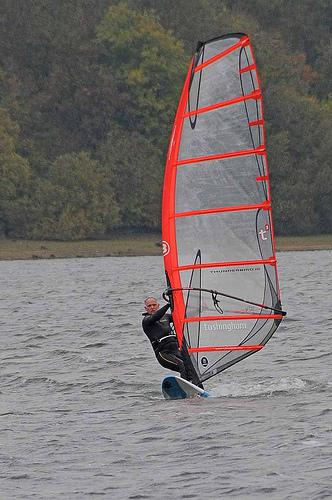Question: what is he doing?
Choices:
A. Skateboarding.
B. Wind surfing.
C. Skiing.
D. Ice skating.
Answer with the letter. Answer: B Question: when was the picture taken?
Choices:
A. Day time.
B. At sunrise.
C. In the evening.
D. At night.
Answer with the letter. Answer: A Question: who in on the board?
Choices:
A. Teenage boy.
B. A woman.
C. A girl.
D. Man.
Answer with the letter. Answer: D Question: where is he surfing?
Choices:
A. Ocean.
B. The water.
C. On a large wave.
D. In the sea.
Answer with the letter. Answer: B 